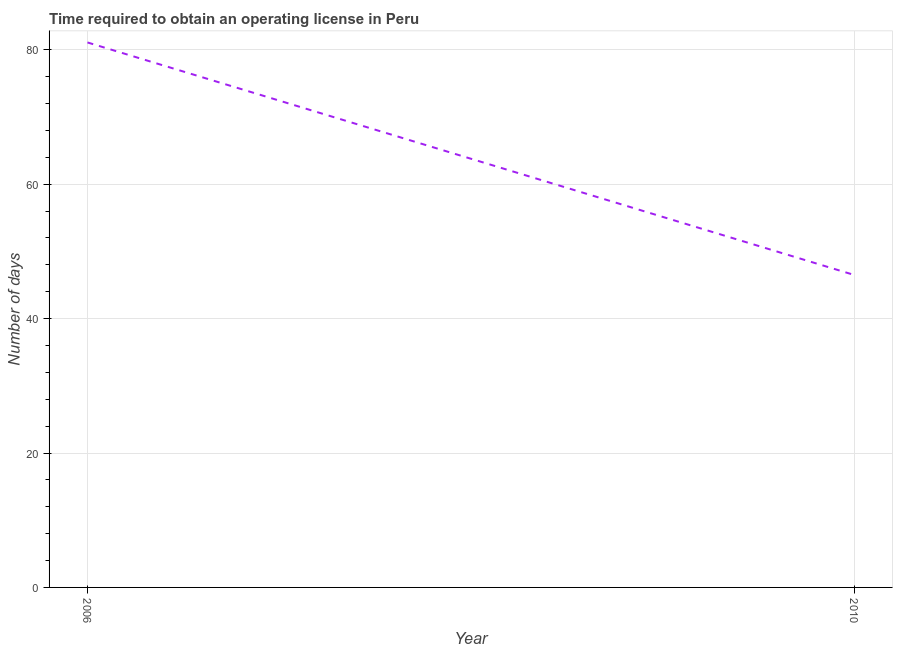What is the number of days to obtain operating license in 2006?
Keep it short and to the point. 81.1. Across all years, what is the maximum number of days to obtain operating license?
Provide a succinct answer. 81.1. Across all years, what is the minimum number of days to obtain operating license?
Make the answer very short. 46.5. What is the sum of the number of days to obtain operating license?
Provide a succinct answer. 127.6. What is the difference between the number of days to obtain operating license in 2006 and 2010?
Ensure brevity in your answer.  34.6. What is the average number of days to obtain operating license per year?
Ensure brevity in your answer.  63.8. What is the median number of days to obtain operating license?
Your answer should be very brief. 63.8. In how many years, is the number of days to obtain operating license greater than 16 days?
Provide a succinct answer. 2. Do a majority of the years between 2010 and 2006 (inclusive) have number of days to obtain operating license greater than 12 days?
Provide a short and direct response. No. What is the ratio of the number of days to obtain operating license in 2006 to that in 2010?
Ensure brevity in your answer.  1.74. Does the number of days to obtain operating license monotonically increase over the years?
Offer a terse response. No. How many lines are there?
Offer a very short reply. 1. Are the values on the major ticks of Y-axis written in scientific E-notation?
Offer a very short reply. No. Does the graph contain grids?
Make the answer very short. Yes. What is the title of the graph?
Provide a succinct answer. Time required to obtain an operating license in Peru. What is the label or title of the Y-axis?
Keep it short and to the point. Number of days. What is the Number of days of 2006?
Provide a succinct answer. 81.1. What is the Number of days in 2010?
Offer a very short reply. 46.5. What is the difference between the Number of days in 2006 and 2010?
Give a very brief answer. 34.6. What is the ratio of the Number of days in 2006 to that in 2010?
Make the answer very short. 1.74. 